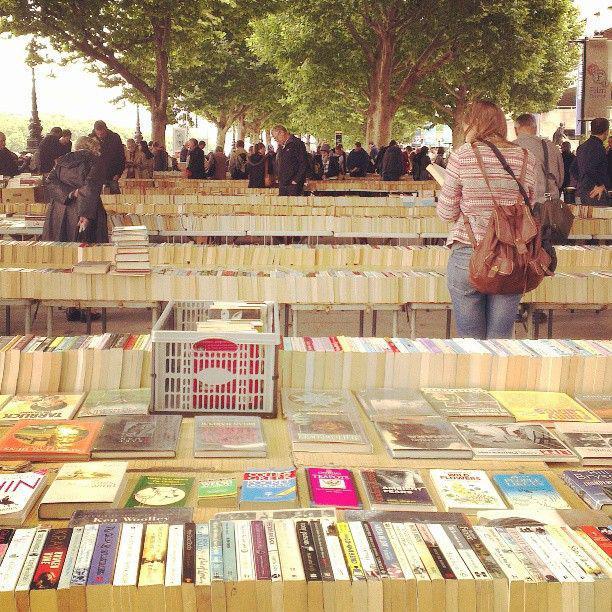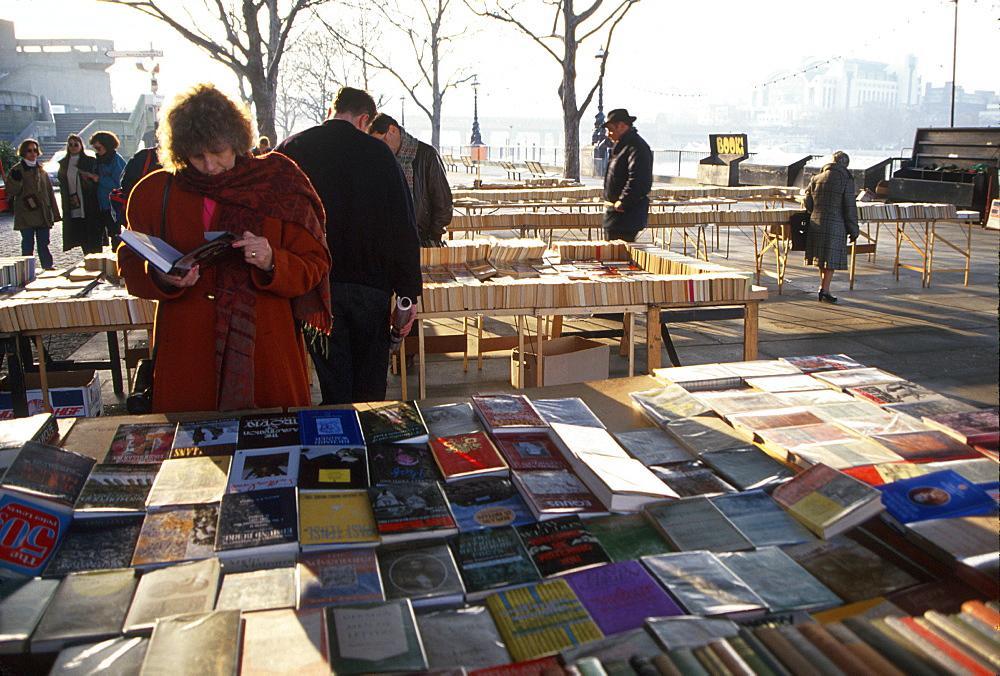The first image is the image on the left, the second image is the image on the right. For the images shown, is this caption "There are fewer than ten people in the image on the left." true? Answer yes or no. No. The first image is the image on the left, the second image is the image on the right. For the images displayed, is the sentence "The left image is a head-on view of a long display of books under a narrow overhead structure, with the books stacked flat in several center rows, flanked on each side by a row of books stacked vertically, with people browsing on either side." factually correct? Answer yes or no. No. 